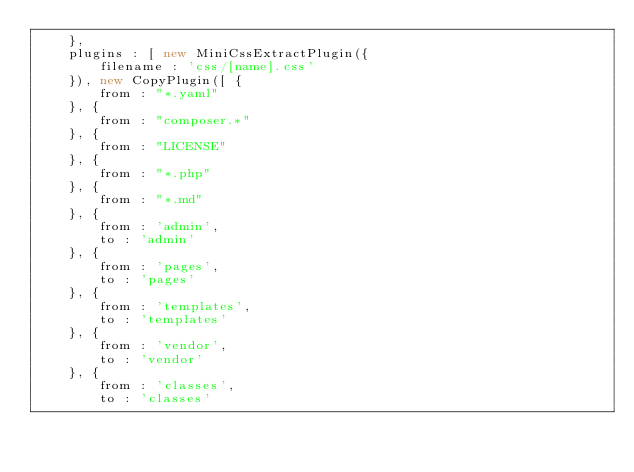Convert code to text. <code><loc_0><loc_0><loc_500><loc_500><_JavaScript_>	},
	plugins : [ new MiniCssExtractPlugin({
		filename : 'css/[name].css'
	}), new CopyPlugin([ {
		from : "*.yaml"
	}, {
		from : "composer.*"
	}, {
		from : "LICENSE"
	}, {
		from : "*.php"
	}, {
		from : "*.md"
	}, {
		from : 'admin',
		to : 'admin'
	}, {
		from : 'pages',
		to : 'pages'
	}, {
		from : 'templates',
		to : 'templates'
	}, {
		from : 'vendor',
		to : 'vendor'
	}, {
		from : 'classes',
		to : 'classes'</code> 